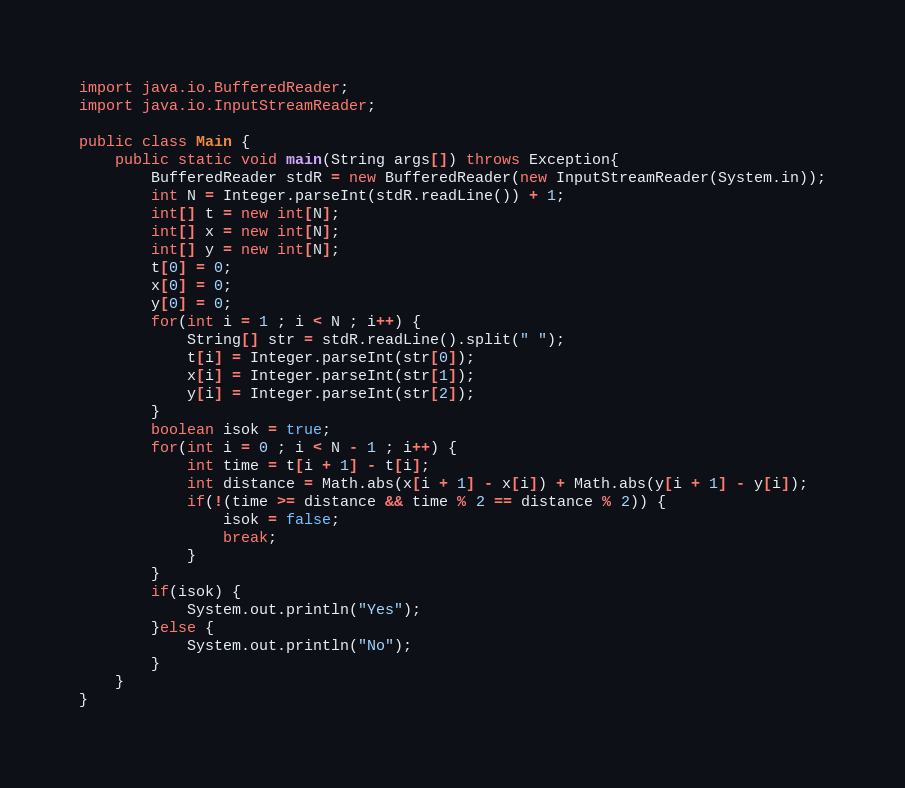Convert code to text. <code><loc_0><loc_0><loc_500><loc_500><_Java_>import java.io.BufferedReader;
import java.io.InputStreamReader;

public class Main {
    public static void main(String args[]) throws Exception{
        BufferedReader stdR = new BufferedReader(new InputStreamReader(System.in));
        int N = Integer.parseInt(stdR.readLine()) + 1;
        int[] t = new int[N];
        int[] x = new int[N];
        int[] y = new int[N];
        t[0] = 0;
        x[0] = 0;
        y[0] = 0;
        for(int i = 1 ; i < N ; i++) {
            String[] str = stdR.readLine().split(" ");
            t[i] = Integer.parseInt(str[0]);
            x[i] = Integer.parseInt(str[1]);
            y[i] = Integer.parseInt(str[2]);
        }
        boolean isok = true;
        for(int i = 0 ; i < N - 1 ; i++) {
            int time = t[i + 1] - t[i];
            int distance = Math.abs(x[i + 1] - x[i]) + Math.abs(y[i + 1] - y[i]);
            if(!(time >= distance && time % 2 == distance % 2)) {
                isok = false;
                break;
            }
        }
        if(isok) {
            System.out.println("Yes");
        }else {
            System.out.println("No");
        }
    }
}
</code> 